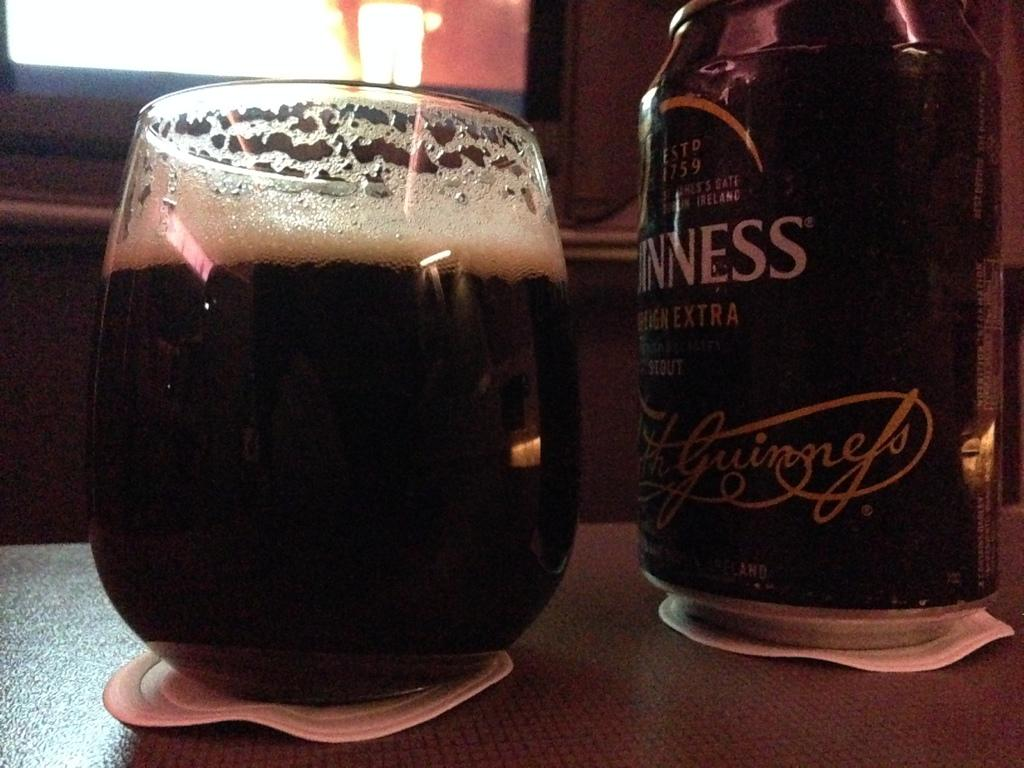<image>
Create a compact narrative representing the image presented. a glass of dark beer is sitting by the bottle of Guinness. 